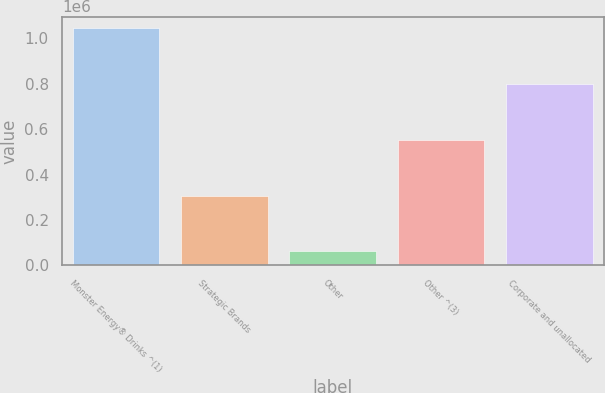Convert chart. <chart><loc_0><loc_0><loc_500><loc_500><bar_chart><fcel>Monster Energy® Drinks ^(1)<fcel>Strategic Brands<fcel>Other<fcel>Other ^(3)<fcel>Corporate and unallocated<nl><fcel>1.04387e+06<fcel>306550<fcel>60777<fcel>552323<fcel>798095<nl></chart> 